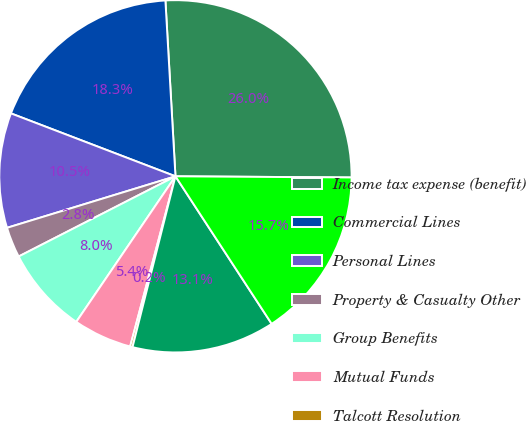<chart> <loc_0><loc_0><loc_500><loc_500><pie_chart><fcel>Income tax expense (benefit)<fcel>Commercial Lines<fcel>Personal Lines<fcel>Property & Casualty Other<fcel>Group Benefits<fcel>Mutual Funds<fcel>Talcott Resolution<fcel>Corporate<fcel>Total income tax expense<nl><fcel>26.02%<fcel>18.28%<fcel>10.54%<fcel>2.8%<fcel>7.96%<fcel>5.38%<fcel>0.22%<fcel>13.12%<fcel>15.7%<nl></chart> 